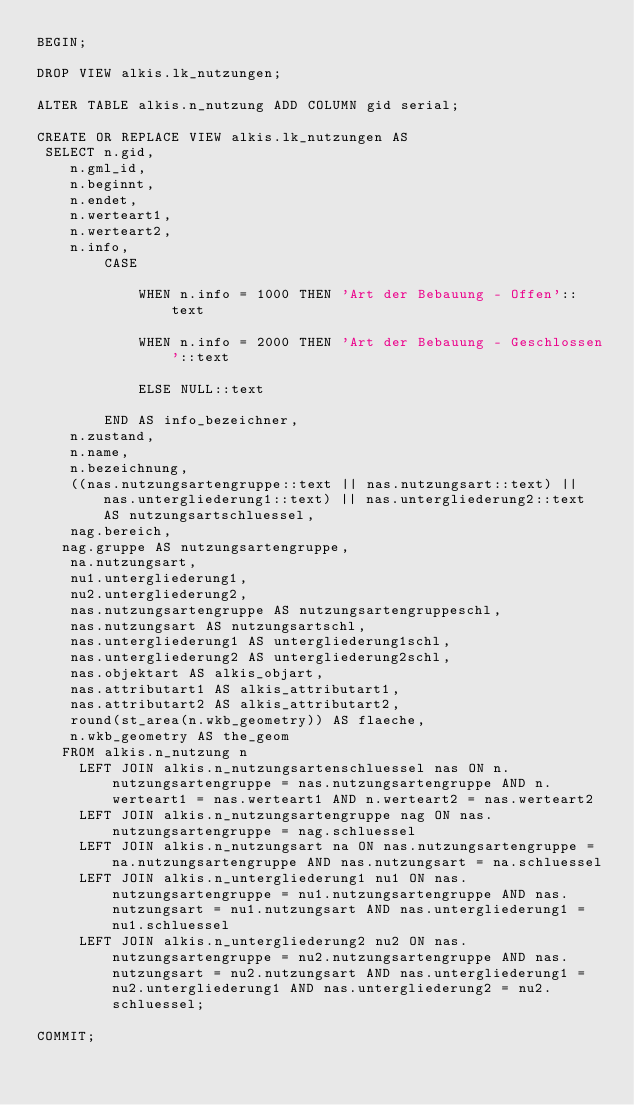Convert code to text. <code><loc_0><loc_0><loc_500><loc_500><_SQL_>BEGIN;

DROP VIEW alkis.lk_nutzungen;

ALTER TABLE alkis.n_nutzung ADD COLUMN gid serial;

CREATE OR REPLACE VIEW alkis.lk_nutzungen AS
 SELECT n.gid,
    n.gml_id,
    n.beginnt,
    n.endet,
    n.werteart1,
    n.werteart2,
    n.info,
        CASE

            WHEN n.info = 1000 THEN 'Art der Bebauung - Offen'::text

            WHEN n.info = 2000 THEN 'Art der Bebauung - Geschlossen'::text

            ELSE NULL::text

        END AS info_bezeichner,
    n.zustand,
    n.name,
    n.bezeichnung,
    ((nas.nutzungsartengruppe::text || nas.nutzungsart::text) || nas.untergliederung1::text) || nas.untergliederung2::text AS nutzungsartschluessel,
    nag.bereich,
   nag.gruppe AS nutzungsartengruppe,
    na.nutzungsart,
    nu1.untergliederung1,
    nu2.untergliederung2,
    nas.nutzungsartengruppe AS nutzungsartengruppeschl,
    nas.nutzungsart AS nutzungsartschl,
    nas.untergliederung1 AS untergliederung1schl,
    nas.untergliederung2 AS untergliederung2schl,
    nas.objektart AS alkis_objart,
    nas.attributart1 AS alkis_attributart1,
    nas.attributart2 AS alkis_attributart2,
    round(st_area(n.wkb_geometry)) AS flaeche,
    n.wkb_geometry AS the_geom
   FROM alkis.n_nutzung n
     LEFT JOIN alkis.n_nutzungsartenschluessel nas ON n.nutzungsartengruppe = nas.nutzungsartengruppe AND n.werteart1 = nas.werteart1 AND n.werteart2 = nas.werteart2
     LEFT JOIN alkis.n_nutzungsartengruppe nag ON nas.nutzungsartengruppe = nag.schluessel
     LEFT JOIN alkis.n_nutzungsart na ON nas.nutzungsartengruppe = na.nutzungsartengruppe AND nas.nutzungsart = na.schluessel
     LEFT JOIN alkis.n_untergliederung1 nu1 ON nas.nutzungsartengruppe = nu1.nutzungsartengruppe AND nas.nutzungsart = nu1.nutzungsart AND nas.untergliederung1 = nu1.schluessel
     LEFT JOIN alkis.n_untergliederung2 nu2 ON nas.nutzungsartengruppe = nu2.nutzungsartengruppe AND nas.nutzungsart = nu2.nutzungsart AND nas.untergliederung1 = nu2.untergliederung1 AND nas.untergliederung2 = nu2.schluessel;

COMMIT;
</code> 